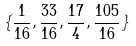Convert formula to latex. <formula><loc_0><loc_0><loc_500><loc_500>\{ \frac { 1 } { 1 6 } , \frac { 3 3 } { 1 6 } , \frac { 1 7 } { 4 } , \frac { 1 0 5 } { 1 6 } \}</formula> 